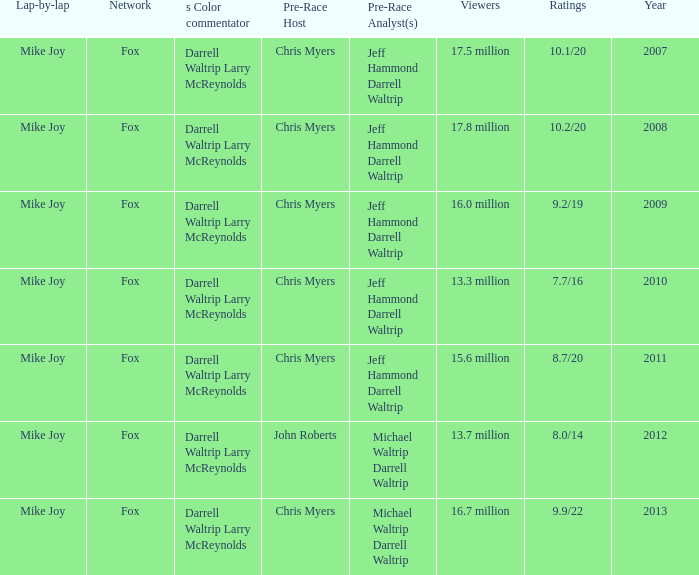How many Ratings did the 2013 Year have? 9.9/22. 